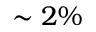<formula> <loc_0><loc_0><loc_500><loc_500>\sim 2 \%</formula> 